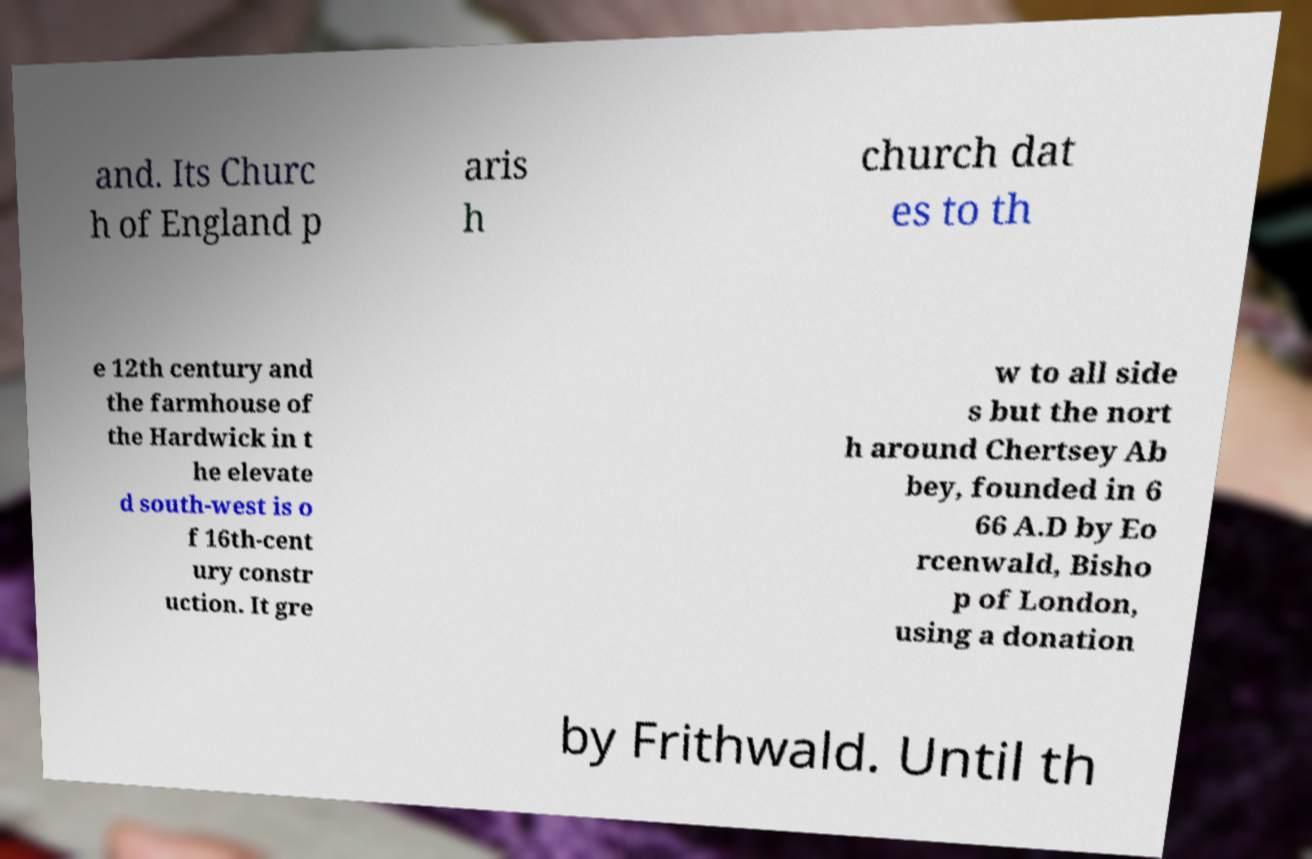There's text embedded in this image that I need extracted. Can you transcribe it verbatim? and. Its Churc h of England p aris h church dat es to th e 12th century and the farmhouse of the Hardwick in t he elevate d south-west is o f 16th-cent ury constr uction. It gre w to all side s but the nort h around Chertsey Ab bey, founded in 6 66 A.D by Eo rcenwald, Bisho p of London, using a donation by Frithwald. Until th 